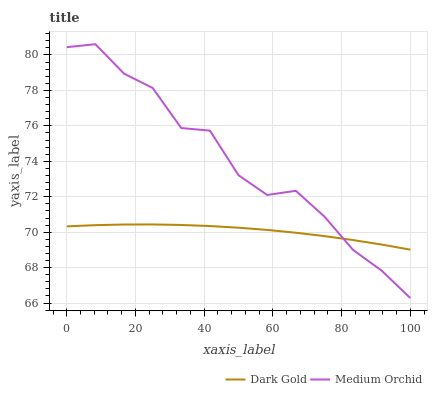Does Dark Gold have the minimum area under the curve?
Answer yes or no. Yes. Does Medium Orchid have the maximum area under the curve?
Answer yes or no. Yes. Does Dark Gold have the maximum area under the curve?
Answer yes or no. No. Is Dark Gold the smoothest?
Answer yes or no. Yes. Is Medium Orchid the roughest?
Answer yes or no. Yes. Is Dark Gold the roughest?
Answer yes or no. No. Does Medium Orchid have the lowest value?
Answer yes or no. Yes. Does Dark Gold have the lowest value?
Answer yes or no. No. Does Medium Orchid have the highest value?
Answer yes or no. Yes. Does Dark Gold have the highest value?
Answer yes or no. No. Does Medium Orchid intersect Dark Gold?
Answer yes or no. Yes. Is Medium Orchid less than Dark Gold?
Answer yes or no. No. Is Medium Orchid greater than Dark Gold?
Answer yes or no. No. 